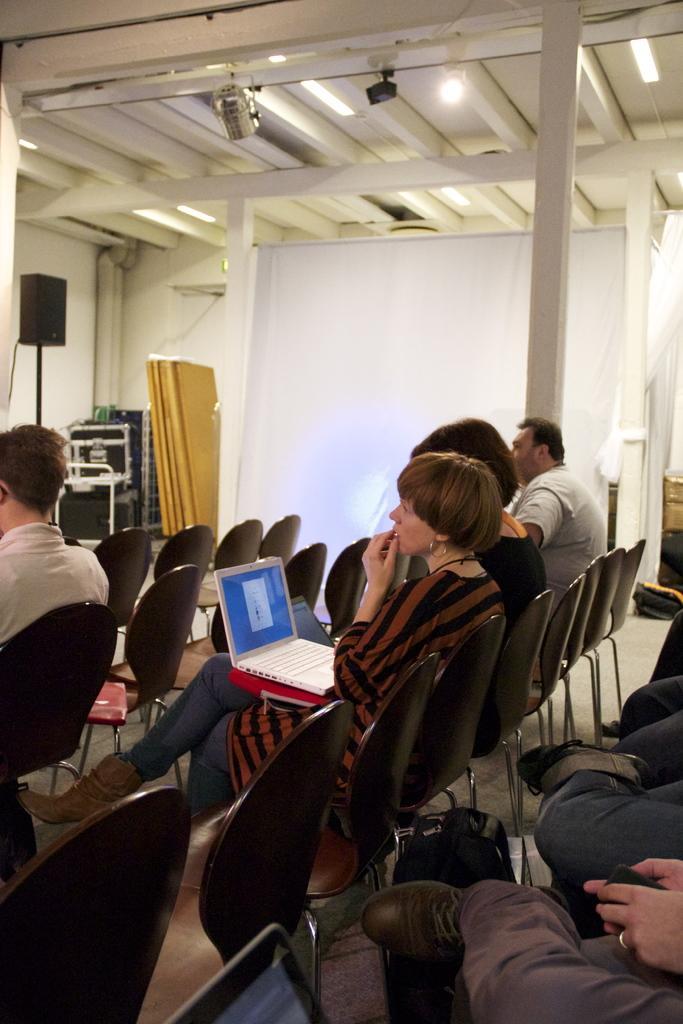Describe this image in one or two sentences. In this image I can see a woman sitting on a chair holding laptop on her lap. I can see many other people at the right corner of the image sitting and at the left corner of the image I can see another person sitting on the chair. This is a wooden pillar. This is a rooftop where lamp is attached. I can see a speaker with a stand and here there are some objects which are placed at a corner of the room. I think these are the pipe lines. This is a white cloth which is hanged. 